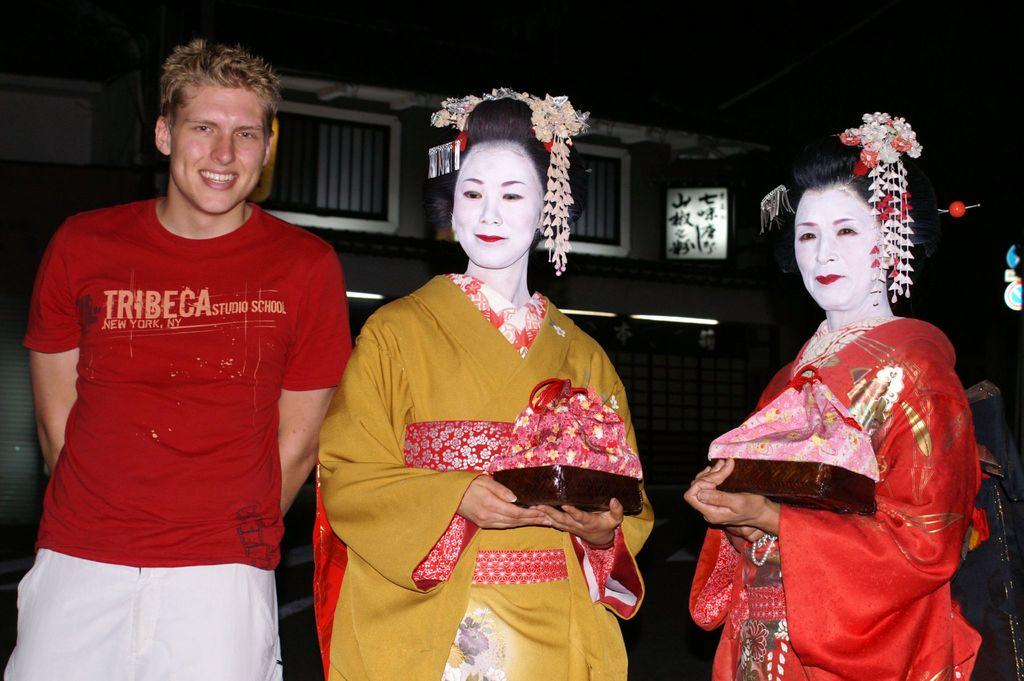<image>
Share a concise interpretation of the image provided. A man in a red Tribeca shirt stands next to two geishas 